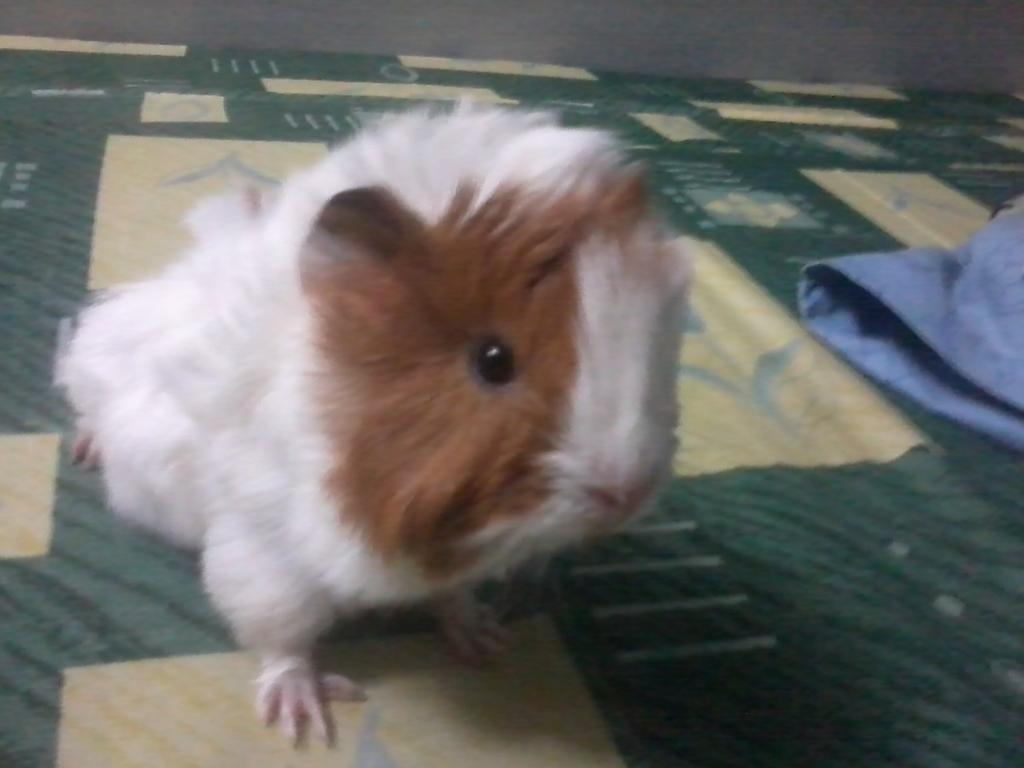How would you summarize this image in a sentence or two? In this image we can see an animal on a mat. On the right side, we can see a cloth. At the top we can see a wall. 